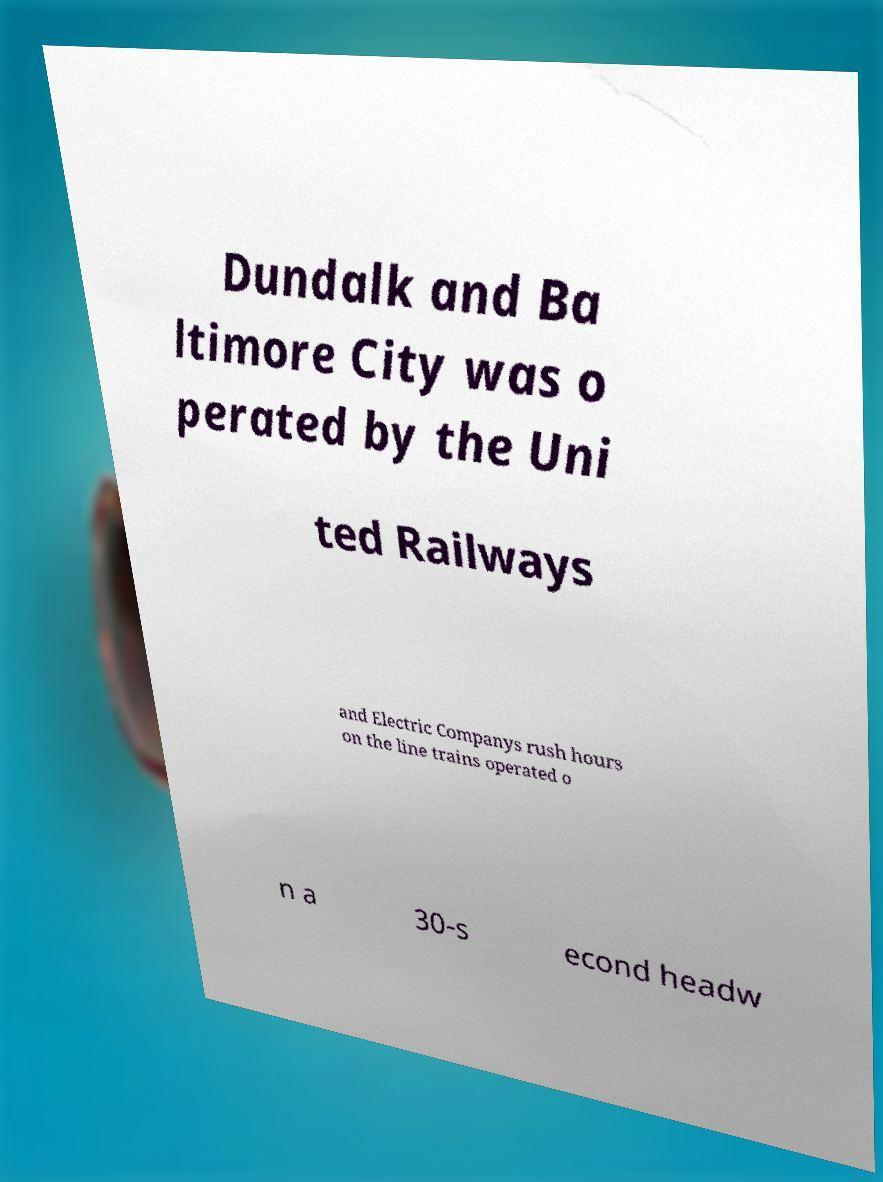Can you accurately transcribe the text from the provided image for me? Dundalk and Ba ltimore City was o perated by the Uni ted Railways and Electric Companys rush hours on the line trains operated o n a 30-s econd headw 